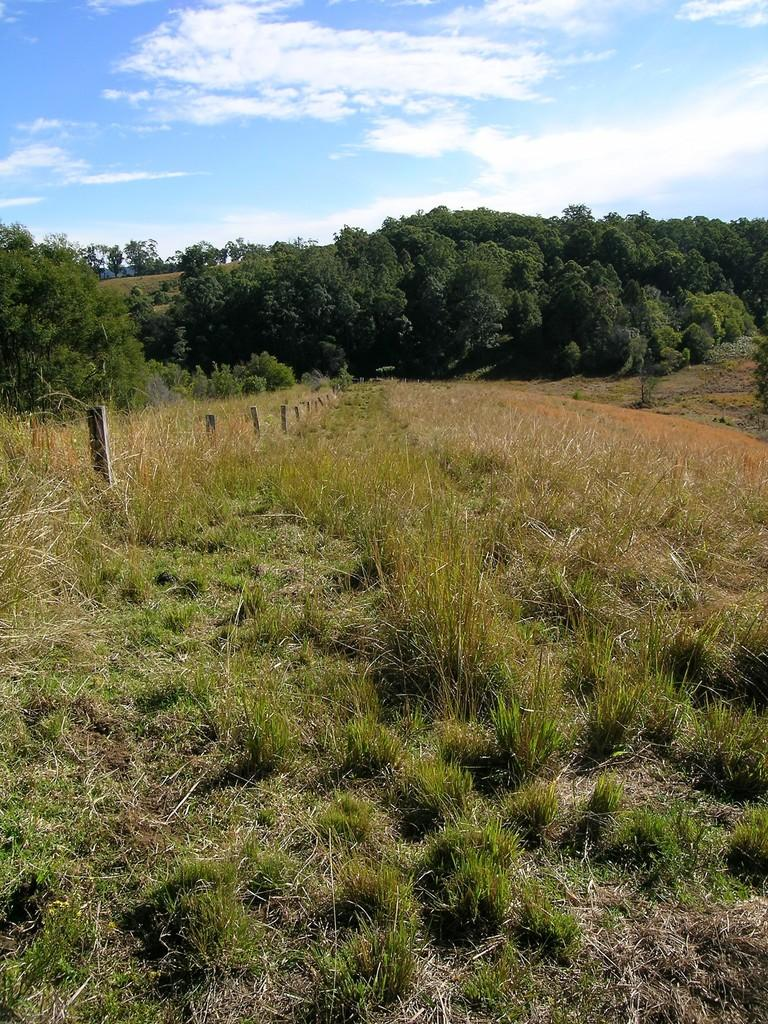What type of vegetation can be seen in the image? There is grass and trees in the image. What material are the sticks made of in the image? The sticks in the image are made of wood. What is visible in the background of the image? The sky is visible in the background of the image. What can be seen in the sky in the image? Clouds are present in the sky. What type of cord is used to tie the beef in the image? There is no cord or beef present in the image. 